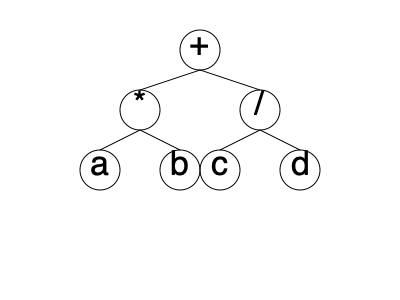Given the tree diagram representing the precedence of arithmetic operators in C++, which expression does this tree structure correspond to? To determine the expression represented by this tree diagram, we need to analyze it from bottom to top, following the rules of operator precedence in C++:

1. The bottom level of the tree contains the operands: a, b, c, and d.

2. Moving up, we see that 'a' and 'b' are connected to a '*' operator. This means a and b are multiplied: a * b

3. On the same level, 'c' and 'd' are connected to a '/' operator. This means c is divided by d: c / d

4. At the top level, we see a '+' operator connecting the results of steps 2 and 3.

5. Combining these operations, we get: (a * b) + (c / d)

The parentheses are important here to show that the multiplication and division operations are performed before the addition, as indicated by their lower position in the tree.

In C++, multiplication and division have the same precedence and are evaluated left to right, which is correctly represented in this tree by placing them at the same level.

Addition has lower precedence than multiplication and division, which is why it's at the top of the tree, indicating it's the last operation to be performed.
Answer: (a * b) + (c / d) 